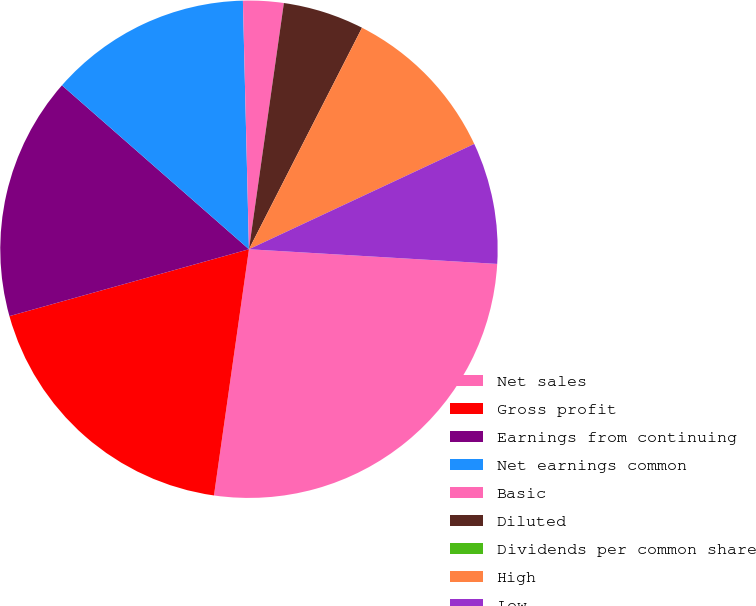Convert chart to OTSL. <chart><loc_0><loc_0><loc_500><loc_500><pie_chart><fcel>Net sales<fcel>Gross profit<fcel>Earnings from continuing<fcel>Net earnings common<fcel>Basic<fcel>Diluted<fcel>Dividends per common share<fcel>High<fcel>Low<nl><fcel>26.31%<fcel>18.42%<fcel>15.79%<fcel>13.16%<fcel>2.63%<fcel>5.27%<fcel>0.0%<fcel>10.53%<fcel>7.9%<nl></chart> 